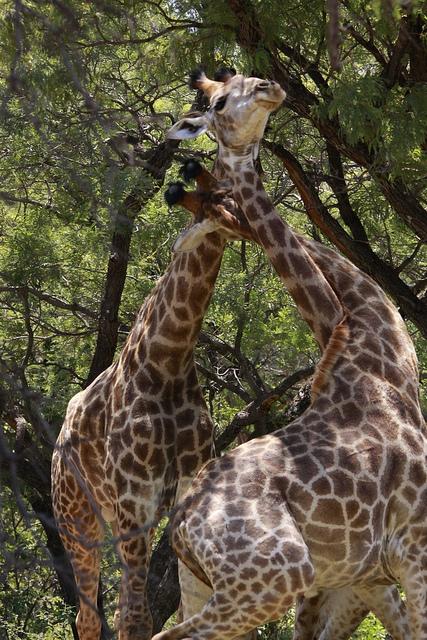How many Giraffes are in this image?
Short answer required. 2. What is the giraffe eating?
Quick response, please. Leaves. Are the giraffes under the trees?
Write a very short answer. Yes. 